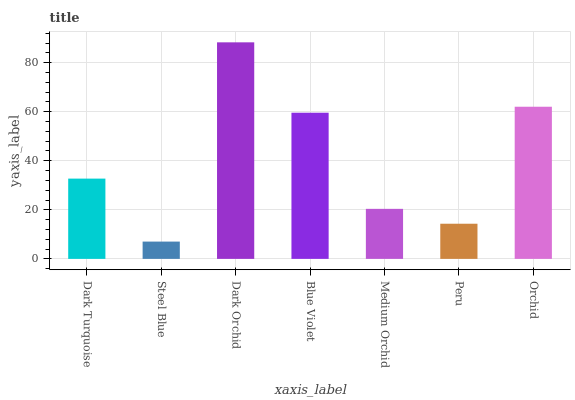Is Steel Blue the minimum?
Answer yes or no. Yes. Is Dark Orchid the maximum?
Answer yes or no. Yes. Is Dark Orchid the minimum?
Answer yes or no. No. Is Steel Blue the maximum?
Answer yes or no. No. Is Dark Orchid greater than Steel Blue?
Answer yes or no. Yes. Is Steel Blue less than Dark Orchid?
Answer yes or no. Yes. Is Steel Blue greater than Dark Orchid?
Answer yes or no. No. Is Dark Orchid less than Steel Blue?
Answer yes or no. No. Is Dark Turquoise the high median?
Answer yes or no. Yes. Is Dark Turquoise the low median?
Answer yes or no. Yes. Is Blue Violet the high median?
Answer yes or no. No. Is Blue Violet the low median?
Answer yes or no. No. 